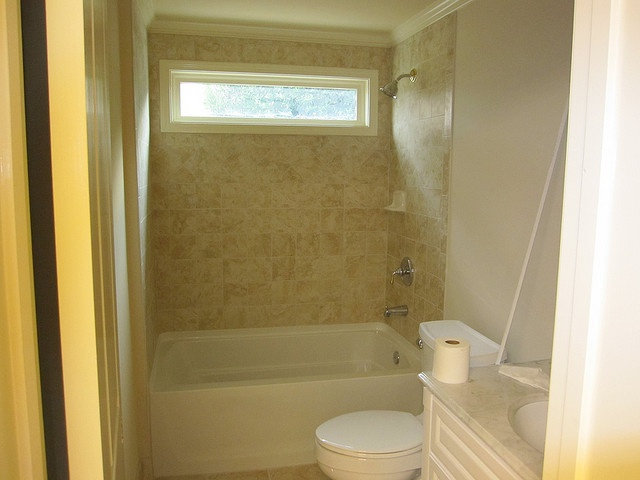Describe the objects in this image and their specific colors. I can see toilet in tan tones and sink in tan and olive tones in this image. 